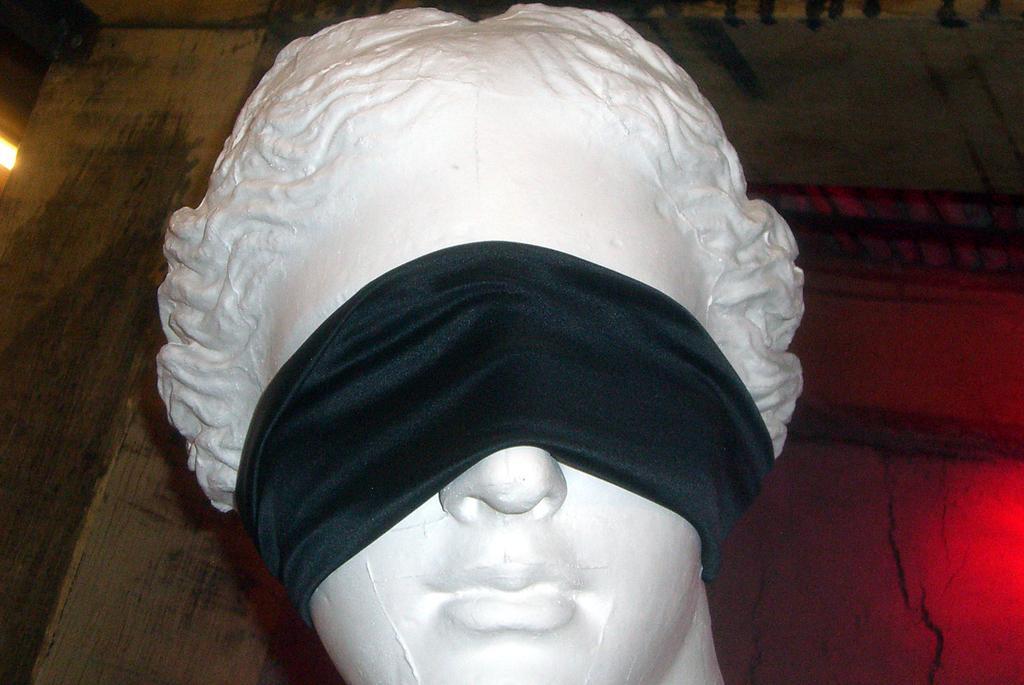Please provide a concise description of this image. In this image we can see a statue with blindfold. 